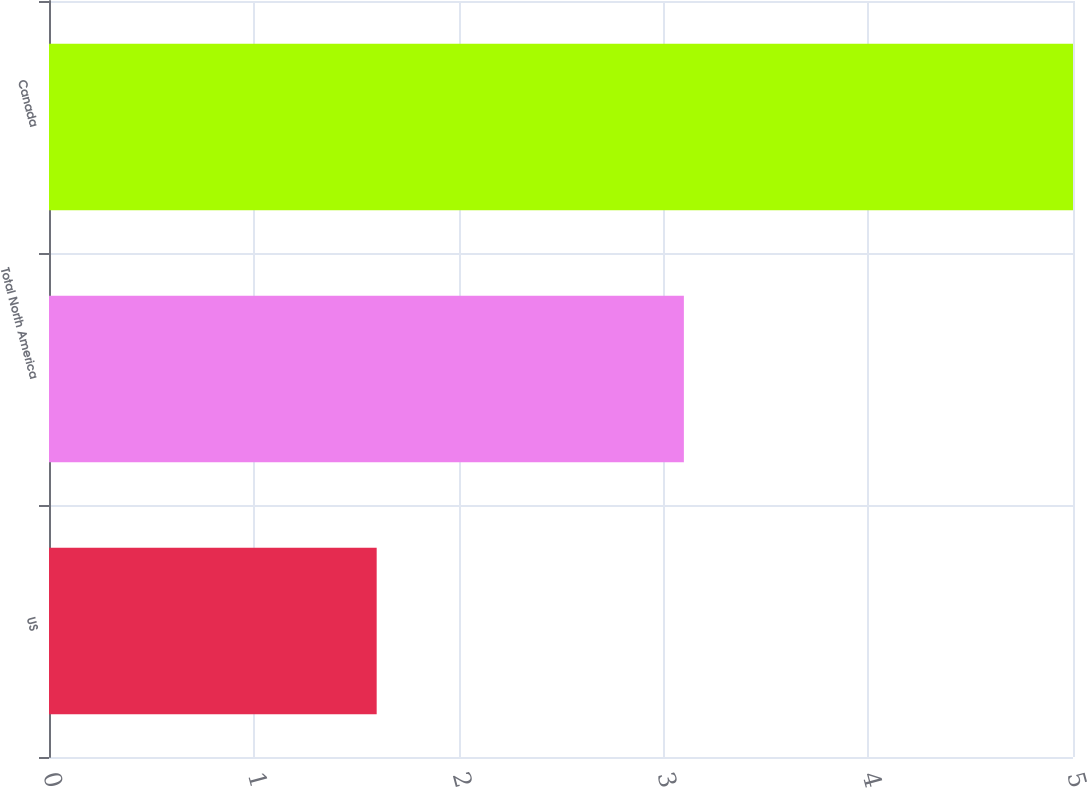Convert chart to OTSL. <chart><loc_0><loc_0><loc_500><loc_500><bar_chart><fcel>US<fcel>Total North America<fcel>Canada<nl><fcel>1.6<fcel>3.1<fcel>5<nl></chart> 